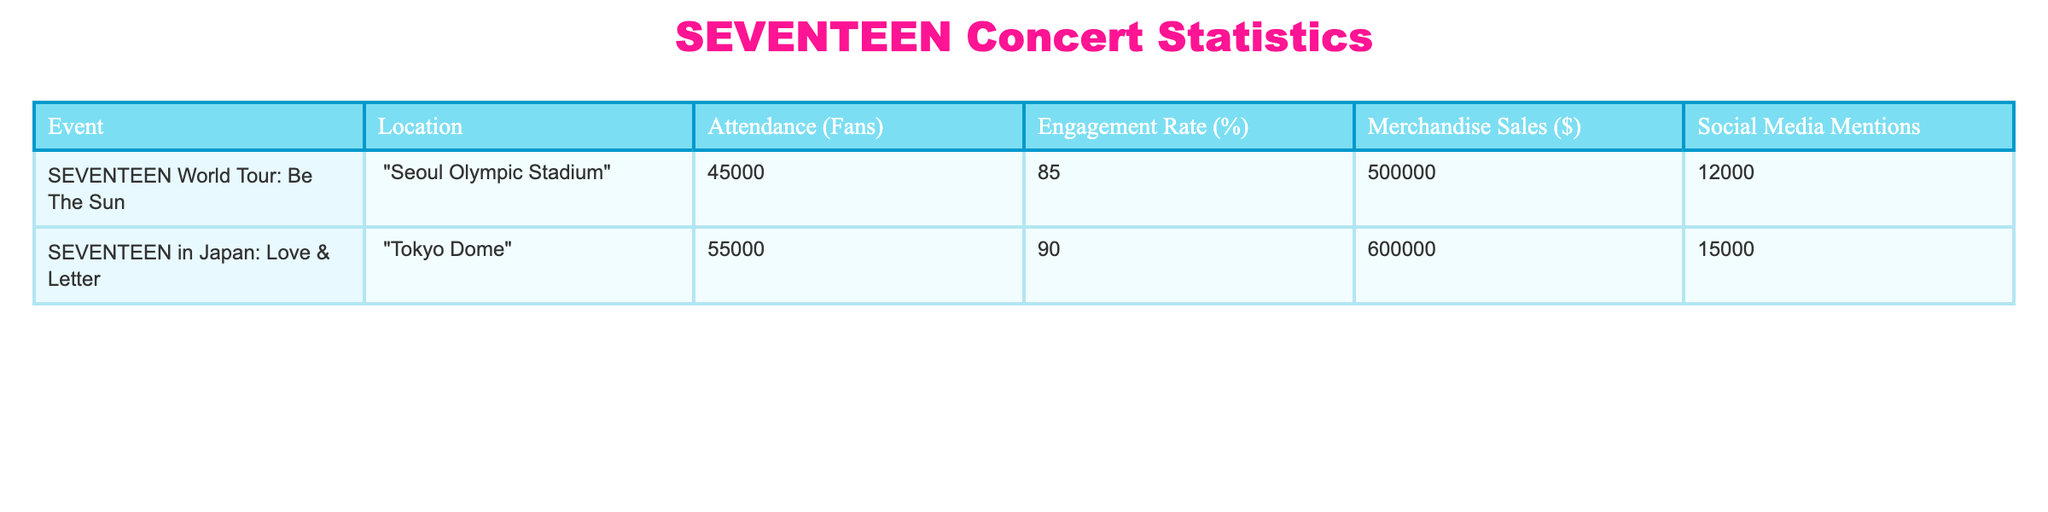What is the engagement rate for the concert in Tokyo Dome? The table shows a value of 90% for the engagement rate in the row corresponding to "SEVENTEEN in Japan: Love & Letter" at the Tokyo Dome.
Answer: 90% Which event had the highest merchandise sales? By comparing the merchandise sales for both events, 600,000 dollars for the Tokyo Dome and 500,000 dollars for the Seoul Olympic Stadium, it is evident that the Tokyo Dome event had the highest sales.
Answer: Tokyo Dome What is the total attendance across both events? The total attendance is found by summing the attendance figures: 45,000 (Seoul Olympic Stadium) + 55,000 (Tokyo Dome) = 100,000.
Answer: 100,000 Did the Seoul Olympic Stadium have a higher engagement rate than the Tokyo Dome? The engagement rate for the Seoul Olympic Stadium is 85% and for the Tokyo Dome is 90%. Since 85% is less than 90%, it did not have a higher engagement rate.
Answer: No What was the average merchandise sales between the two concerts? To find the average merchandise sales, first sum the sales: 500,000 (Seoul) + 600,000 (Tokyo) = 1,100,000, and then divide by the number of events, which is 2. Thus, 1,100,000 / 2 = 550,000.
Answer: 550,000 If you consider social media mentions, which event generated more buzz? The table lists 12,000 mentions for the Seoul event and 15,000 for the Tokyo event. Since 15,000 is greater than 12,000, the Tokyo event generated more buzz on social media.
Answer: Tokyo Dome What was the difference in attendance between the two events? To find the difference, subtract the attendance of the Seoul event (45,000) from the Tokyo event (55,000): 55,000 - 45,000 = 10,000.
Answer: 10,000 Is the engagement rate for the concert in Seoul above average (75%)? The engagement rate for Seoul is 85%. Since 85% is greater than 75%, it is above average.
Answer: Yes 